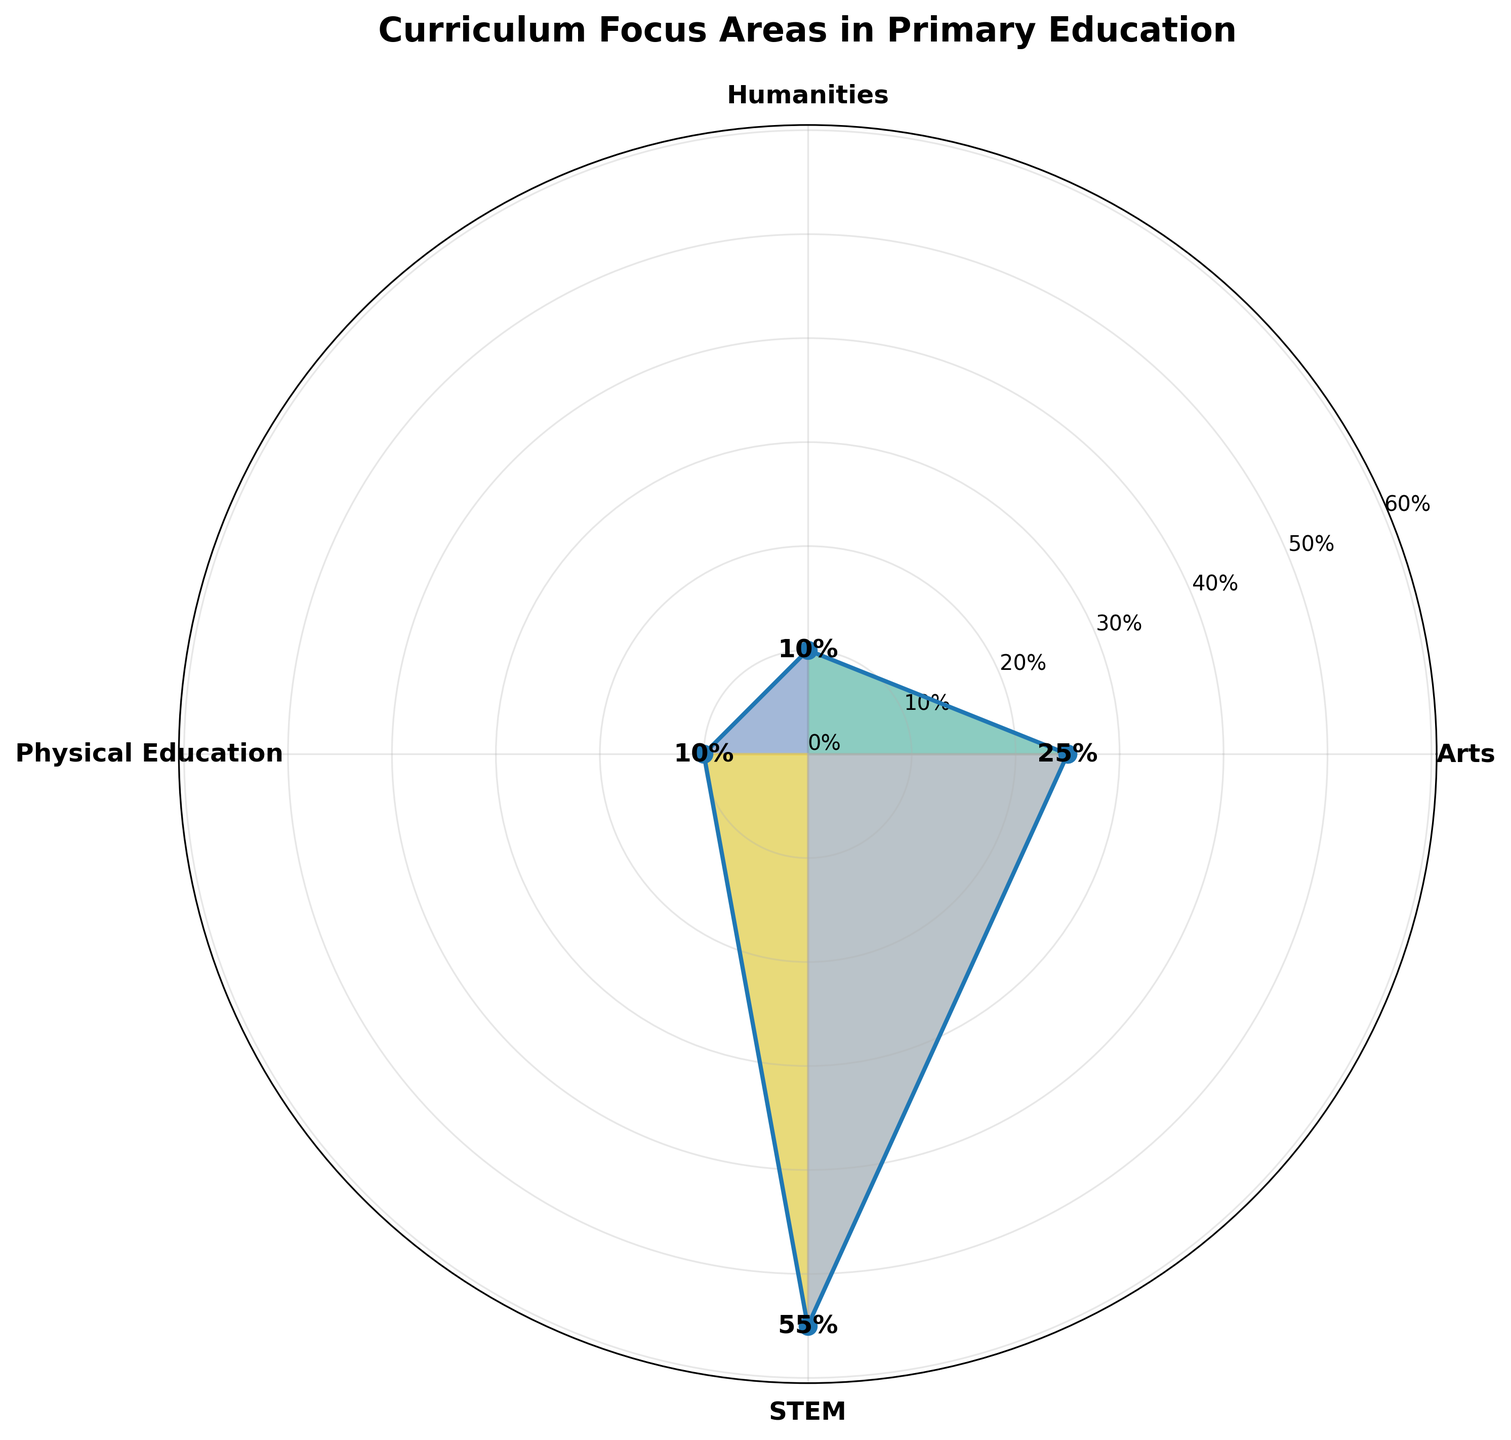Which focus area has the highest percentage in the curriculum? Look at the values plotted on the chart and identify which focus area has the highest value. STEM has the highest percentage of 55% as it combines 30% for Mathematics and 25% for Science.
Answer: STEM Which focus area has the lowest percentage in the curriculum? Check the plotted values on the chart and identify the focus area with the smallest value. Humanities and Physical Education both have 10%, which is the lowest.
Answer: Humanities, Physical Education How much is the total percentage covered by the Arts focus area? Sum up the percentage values for Visual Arts (15%) and Music (10%), which belong to the Arts focus area. 15% + 10% = 25%.
Answer: 25% What percentage does STEM contribute to the curriculum overall? Sum up the percentage values for Mathematics (30%) and Science (25%), which belong to the STEM focus area. 30% + 25% = 55%.
Answer: 55% How does the percentage of Humanities compare to that of Physical Education? Compare the percentage value of Humanities (10%) to Physical Education (10%), they are equal.
Answer: Equal What is the difference in percentages between STEM and Arts focus areas? Calculate the difference by subtracting the Arts percentage (25%) from the STEM percentage (55%). 55% - 25% = 30%.
Answer: 30% Which focus areas have equal contributions to the curriculum? Look at the plotted values and identify any focus areas with the same percentage. Humanities and Physical Education both have a percentage of 10%.
Answer: Humanities, Physical Education How does the percentage for Arts compare to the combined percentage of Humanities and Physical Education? Sum Humanities (10%) and Physical Education (10%), which equals 20%. Then compare this to the Arts percentage (25%). 25% is greater than 20%.
Answer: Greater What is the average percentage of all focus areas? Sum all percentages (55% for STEM, 25% for Arts, 10% for Humanities, 10% for Physical Education) and divide by 4. (55% + 25% + 10% + 10%) / 4 = 25%.
Answer: 25% What is the total percentage of the curriculum represented in the rose chart? Sum all the percentages displayed in the chart. 55% (STEM) + 25% (Arts) + 10% (Humanities) + 10% (Physical Education) = 100%.
Answer: 100% 